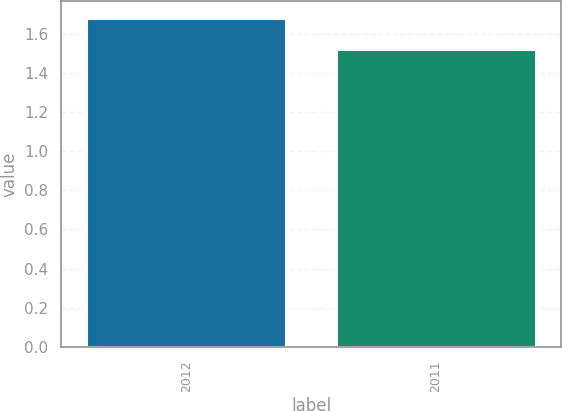<chart> <loc_0><loc_0><loc_500><loc_500><bar_chart><fcel>2012<fcel>2011<nl><fcel>1.68<fcel>1.52<nl></chart> 